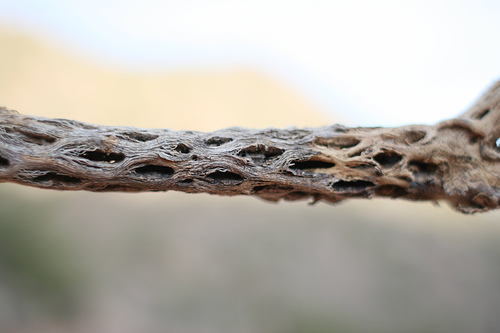<image>
Is there a tree on the air? No. The tree is not positioned on the air. They may be near each other, but the tree is not supported by or resting on top of the air. 